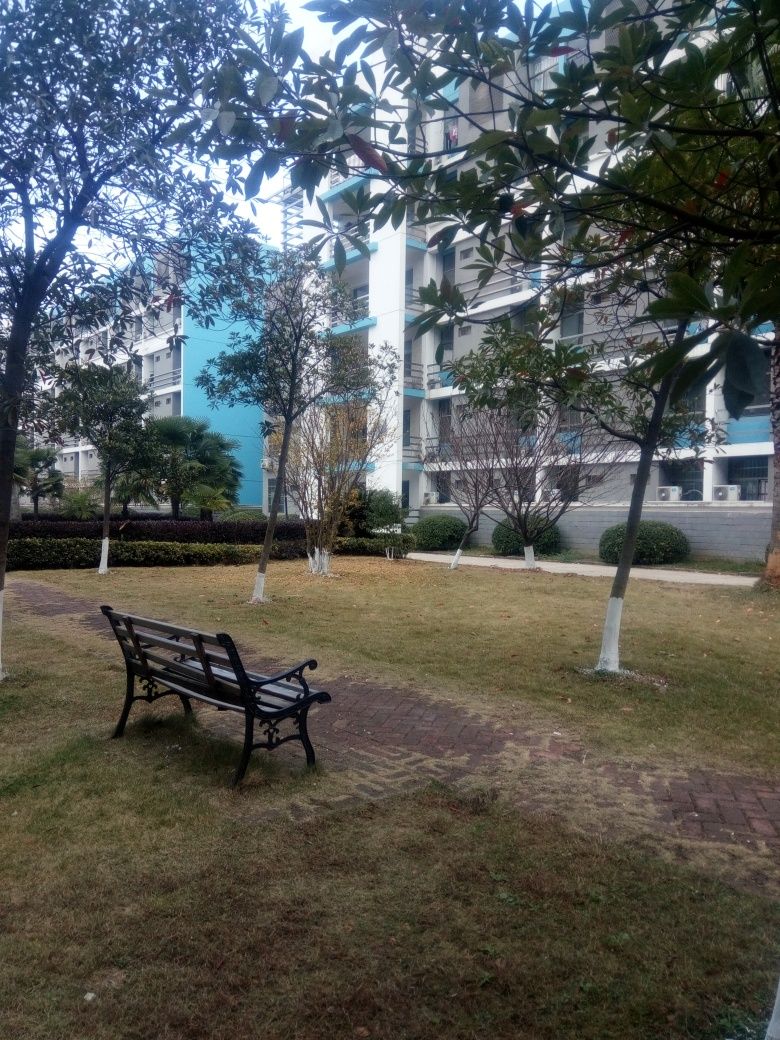What can you infer about the time of day or season? Considering the absence of harsh shadows and the diffuse light, it seems to be either early morning or late afternoon. The fact that the trees are full of leaves suggests it's not winter, so it is likely a season such as spring or autumn. The temperature seems mild, as indicated by the absence of snow or people dressed in warm clothes. 